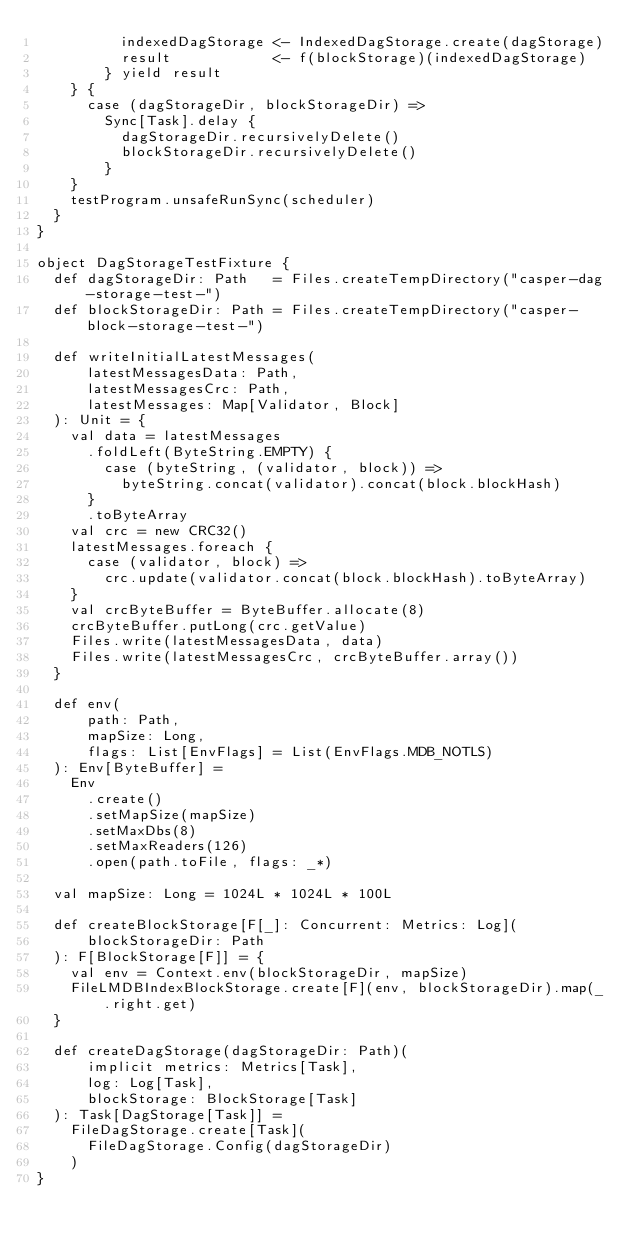Convert code to text. <code><loc_0><loc_0><loc_500><loc_500><_Scala_>          indexedDagStorage <- IndexedDagStorage.create(dagStorage)
          result            <- f(blockStorage)(indexedDagStorage)
        } yield result
    } {
      case (dagStorageDir, blockStorageDir) =>
        Sync[Task].delay {
          dagStorageDir.recursivelyDelete()
          blockStorageDir.recursivelyDelete()
        }
    }
    testProgram.unsafeRunSync(scheduler)
  }
}

object DagStorageTestFixture {
  def dagStorageDir: Path   = Files.createTempDirectory("casper-dag-storage-test-")
  def blockStorageDir: Path = Files.createTempDirectory("casper-block-storage-test-")

  def writeInitialLatestMessages(
      latestMessagesData: Path,
      latestMessagesCrc: Path,
      latestMessages: Map[Validator, Block]
  ): Unit = {
    val data = latestMessages
      .foldLeft(ByteString.EMPTY) {
        case (byteString, (validator, block)) =>
          byteString.concat(validator).concat(block.blockHash)
      }
      .toByteArray
    val crc = new CRC32()
    latestMessages.foreach {
      case (validator, block) =>
        crc.update(validator.concat(block.blockHash).toByteArray)
    }
    val crcByteBuffer = ByteBuffer.allocate(8)
    crcByteBuffer.putLong(crc.getValue)
    Files.write(latestMessagesData, data)
    Files.write(latestMessagesCrc, crcByteBuffer.array())
  }

  def env(
      path: Path,
      mapSize: Long,
      flags: List[EnvFlags] = List(EnvFlags.MDB_NOTLS)
  ): Env[ByteBuffer] =
    Env
      .create()
      .setMapSize(mapSize)
      .setMaxDbs(8)
      .setMaxReaders(126)
      .open(path.toFile, flags: _*)

  val mapSize: Long = 1024L * 1024L * 100L

  def createBlockStorage[F[_]: Concurrent: Metrics: Log](
      blockStorageDir: Path
  ): F[BlockStorage[F]] = {
    val env = Context.env(blockStorageDir, mapSize)
    FileLMDBIndexBlockStorage.create[F](env, blockStorageDir).map(_.right.get)
  }

  def createDagStorage(dagStorageDir: Path)(
      implicit metrics: Metrics[Task],
      log: Log[Task],
      blockStorage: BlockStorage[Task]
  ): Task[DagStorage[Task]] =
    FileDagStorage.create[Task](
      FileDagStorage.Config(dagStorageDir)
    )
}
</code> 